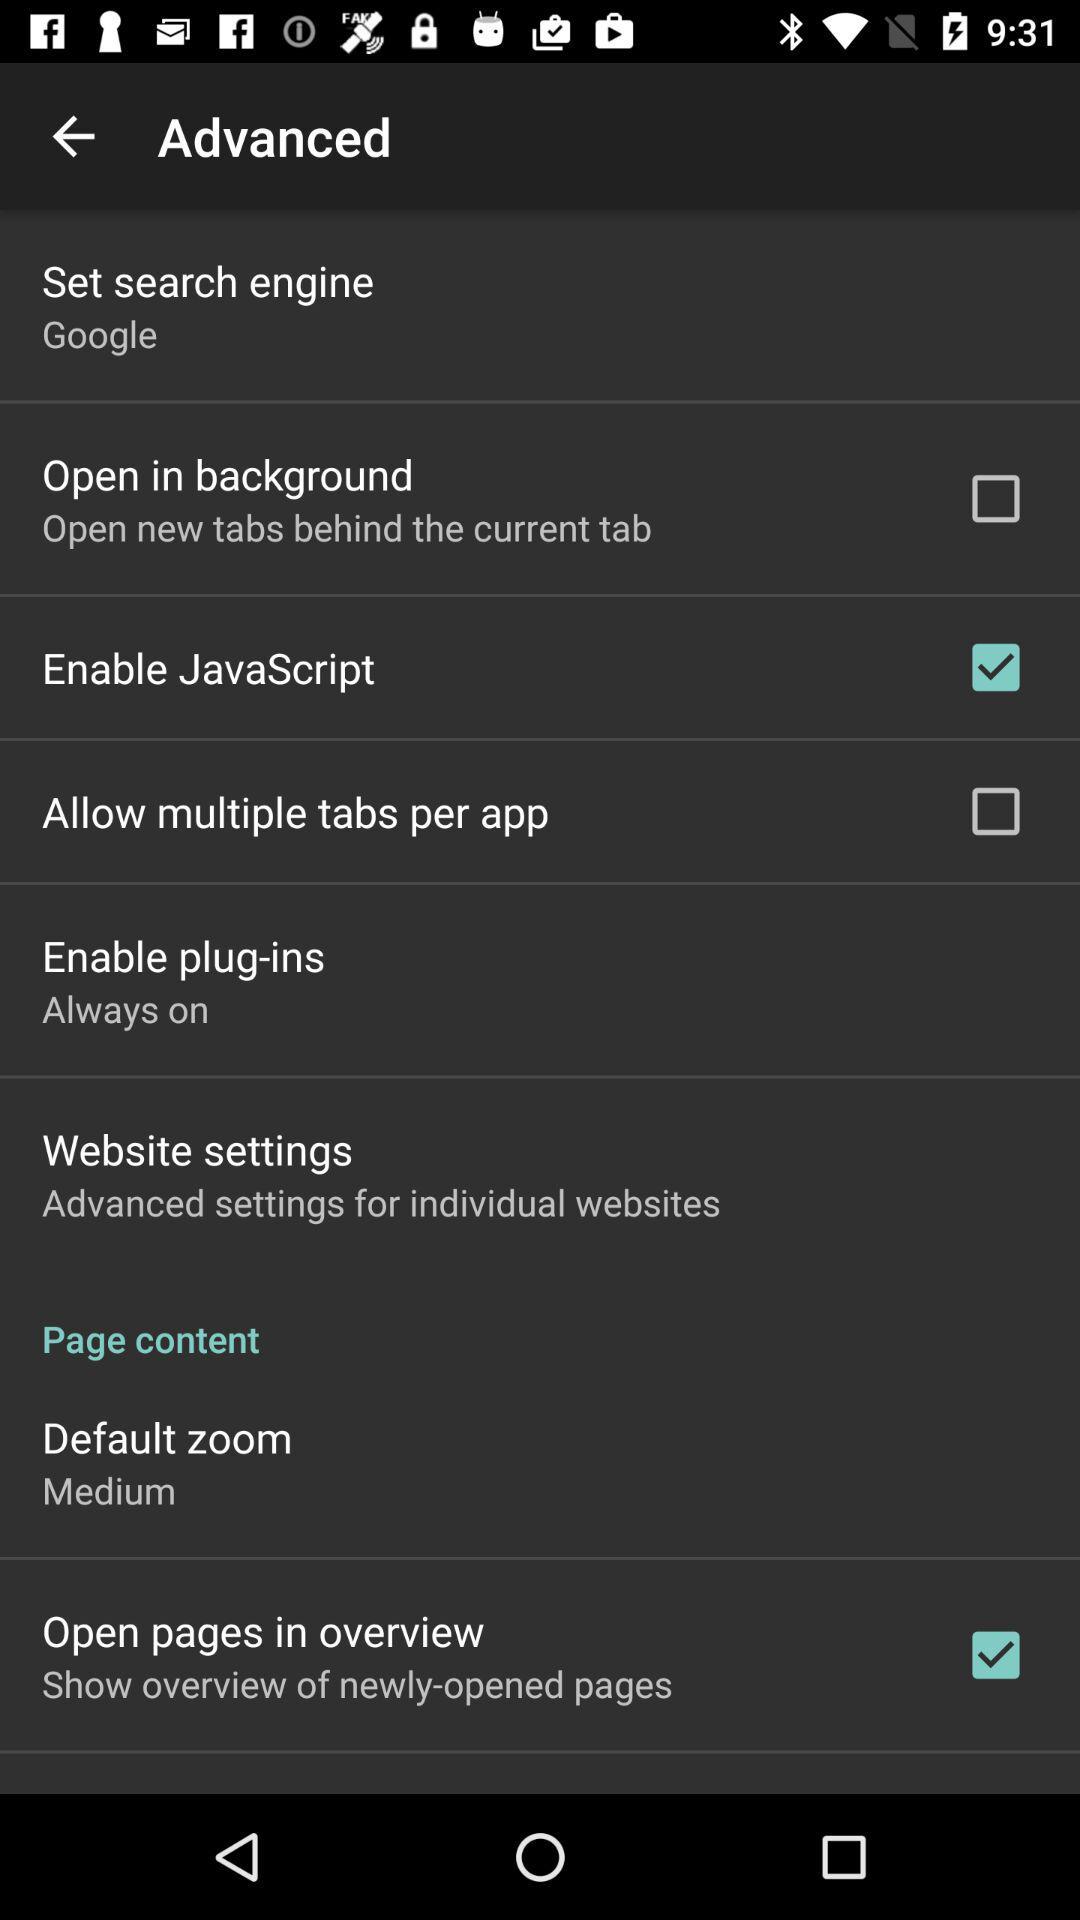What is the status of "Open in background"? The status is "off". 